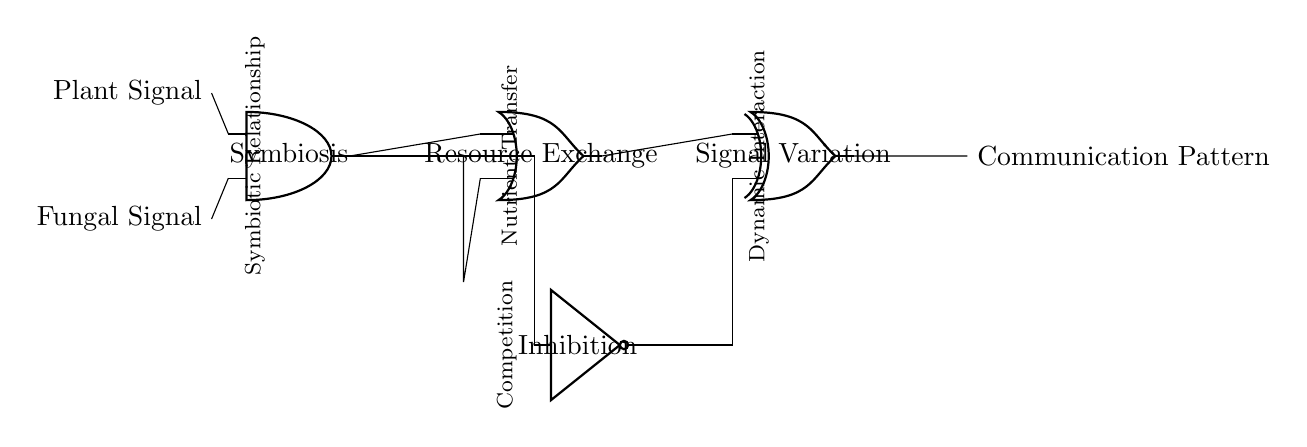What is the type of the first gate in the circuit? The first gate is an AND gate, which is labeled as "Symbiosis" in the diagram, indicating it takes two inputs and produces an output only when both inputs are true.
Answer: AND gate What signals are input into the AND gate? The inputs to the AND gate are the "Plant Signal" and the "Fungal Signal," which are shown on the left side of the diagram.
Answer: Plant Signal and Fungal Signal What is the output of the OR gate? The output of the OR gate is related to "Resource Exchange," which is indicated as the role of the AND gate's output after being processed by the OR gate.
Answer: Resource Exchange How many logic gates are in the circuit? There are four logic gates in the circuit: one AND gate, one OR gate, one NOT gate, and one XOR gate, making a total of four.
Answer: Four What does the NOT gate represent in the circuit? The NOT gate represents "Inhibition," indicating that it inverts the signal it receives from the AND gate to contribute to the overall communication pattern.
Answer: Inhibition What is the final output label of the entire circuit? The final output of the circuit is labeled "Communication Pattern," which is the overall result after the processing of all input signals through the logic gates.
Answer: Communication Pattern What type of relationship does the AND gate represent? The AND gate represents a "Symbiotic Relationship," highlighting the mutual benefits that plants and fungi provide each other in their interaction.
Answer: Symbiotic Relationship 